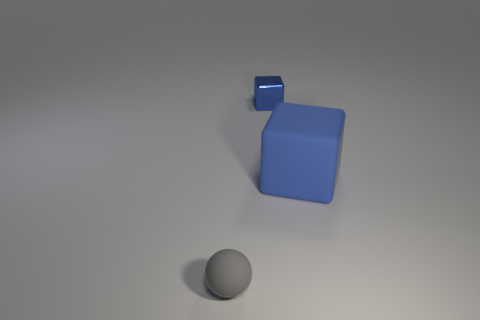Add 1 tiny gray rubber spheres. How many objects exist? 4 Subtract all blocks. How many objects are left? 1 Subtract 1 blocks. How many blocks are left? 1 Subtract 0 purple cubes. How many objects are left? 3 Subtract all red spheres. Subtract all purple cubes. How many spheres are left? 1 Subtract all red cubes. How many brown spheres are left? 0 Subtract all big rubber objects. Subtract all small blue objects. How many objects are left? 1 Add 1 rubber objects. How many rubber objects are left? 3 Add 2 blue rubber blocks. How many blue rubber blocks exist? 3 